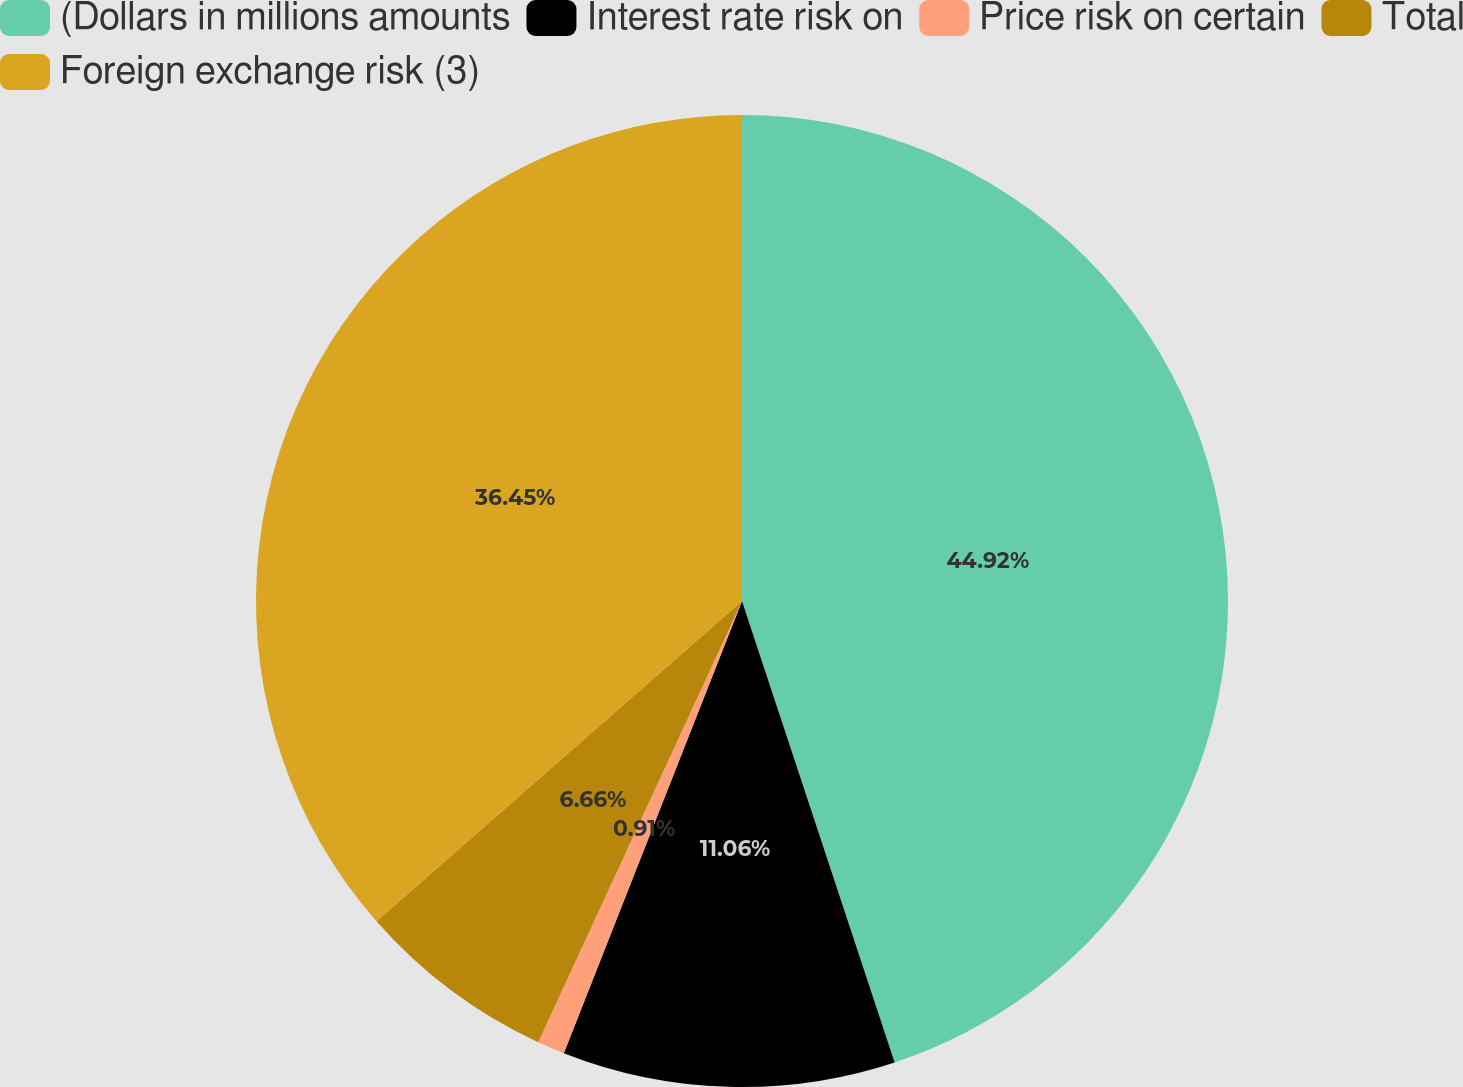Convert chart to OTSL. <chart><loc_0><loc_0><loc_500><loc_500><pie_chart><fcel>(Dollars in millions amounts<fcel>Interest rate risk on<fcel>Price risk on certain<fcel>Total<fcel>Foreign exchange risk (3)<nl><fcel>44.91%<fcel>11.06%<fcel>0.91%<fcel>6.66%<fcel>36.45%<nl></chart> 